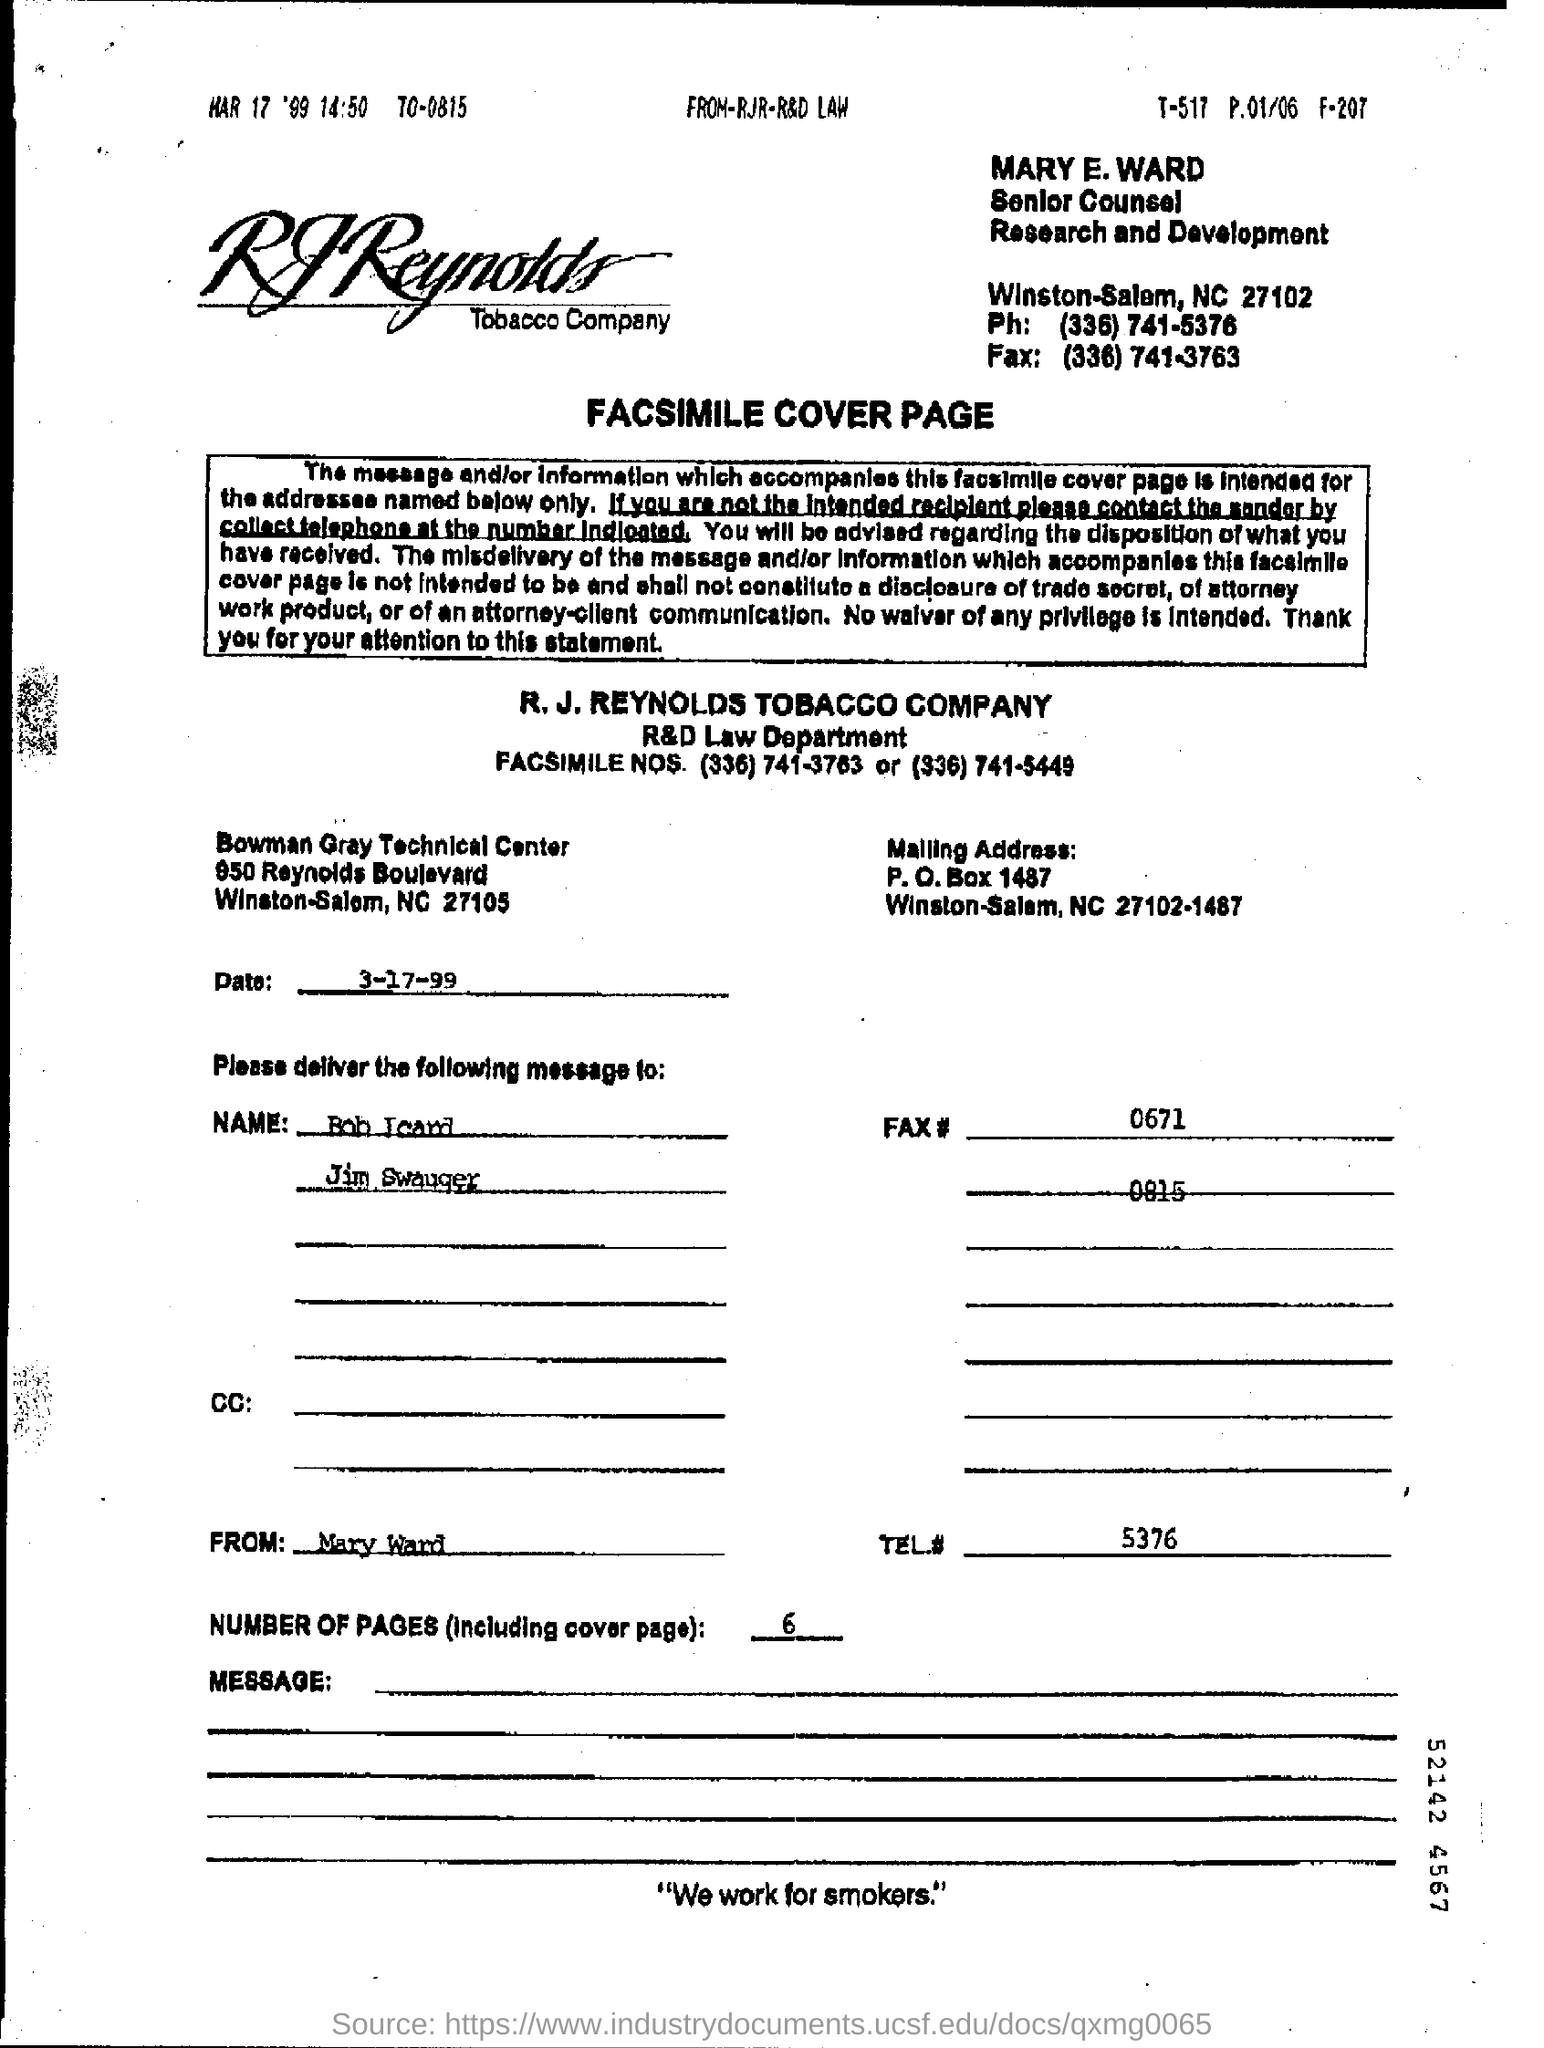What is the date on the document?
Your answer should be very brief. 3-17-99. What is TEL #?
Keep it short and to the point. 5376. What are the Number of Pages (including Cover page)?
Offer a terse response. 6. 